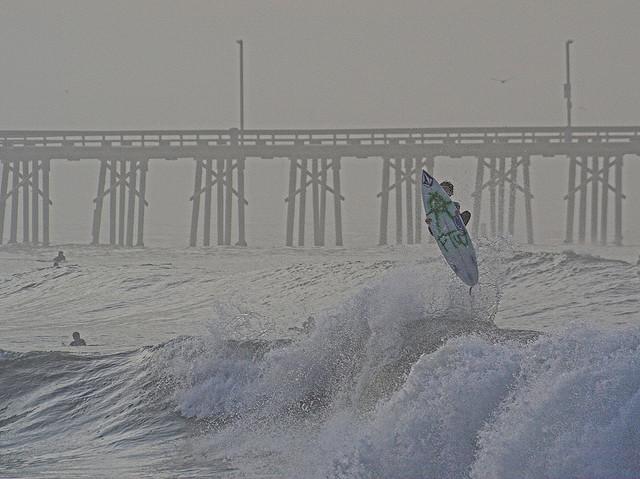Are any people in the water?
Keep it brief. Yes. Is this person driving a car?
Short answer required. No. What is in the distance?
Be succinct. Pier. 